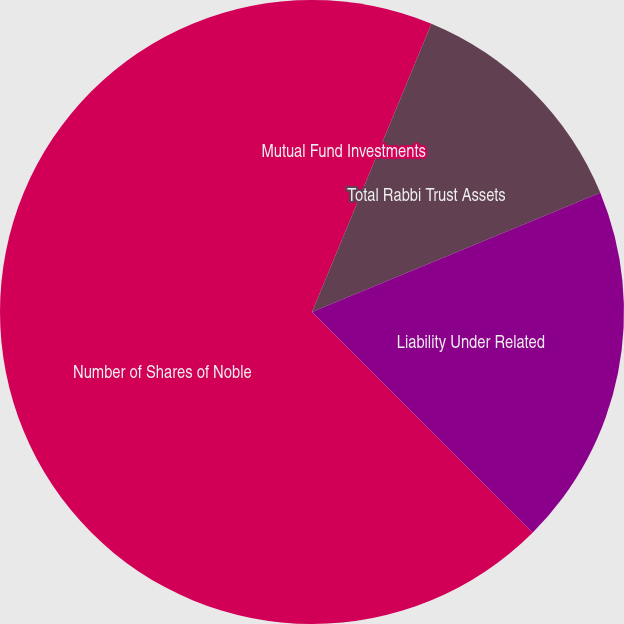<chart> <loc_0><loc_0><loc_500><loc_500><pie_chart><fcel>Mutual Fund Investments<fcel>Noble Energy Common Stock (at<fcel>Total Rabbi Trust Assets<fcel>Liability Under Related<fcel>Number of Shares of Noble<nl><fcel>6.25%<fcel>0.0%<fcel>12.5%<fcel>18.75%<fcel>62.49%<nl></chart> 